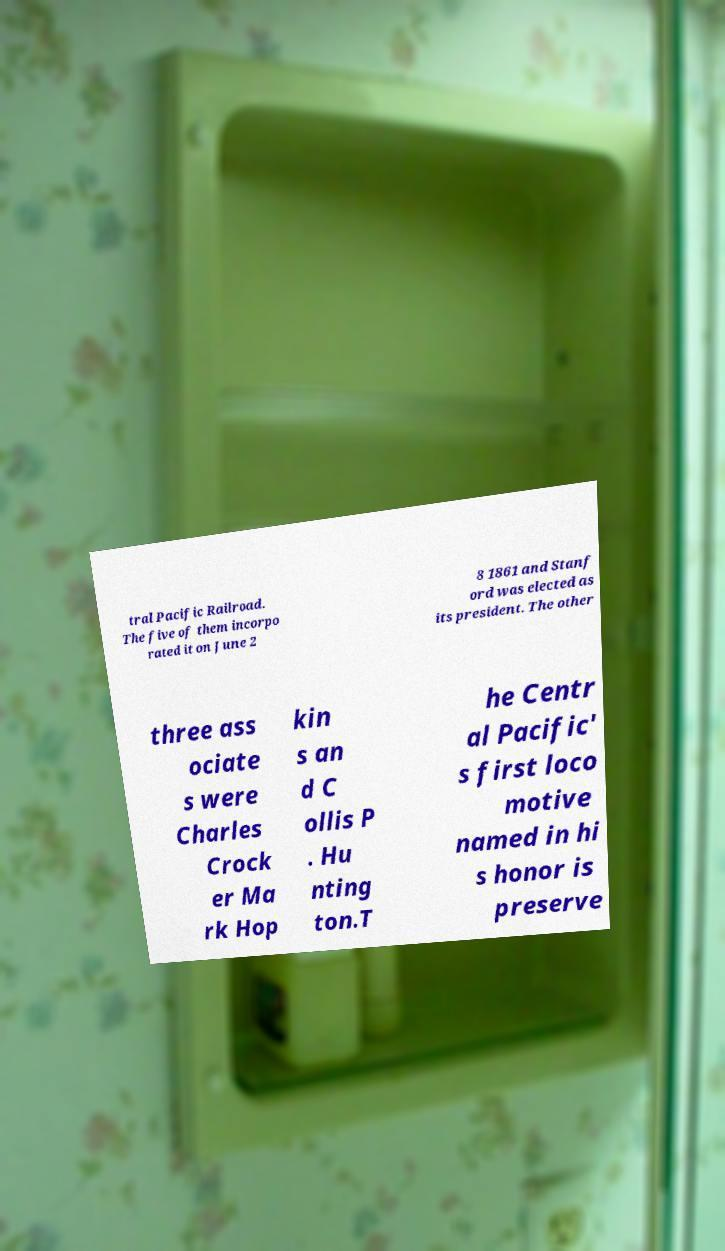I need the written content from this picture converted into text. Can you do that? tral Pacific Railroad. The five of them incorpo rated it on June 2 8 1861 and Stanf ord was elected as its president. The other three ass ociate s were Charles Crock er Ma rk Hop kin s an d C ollis P . Hu nting ton.T he Centr al Pacific' s first loco motive named in hi s honor is preserve 